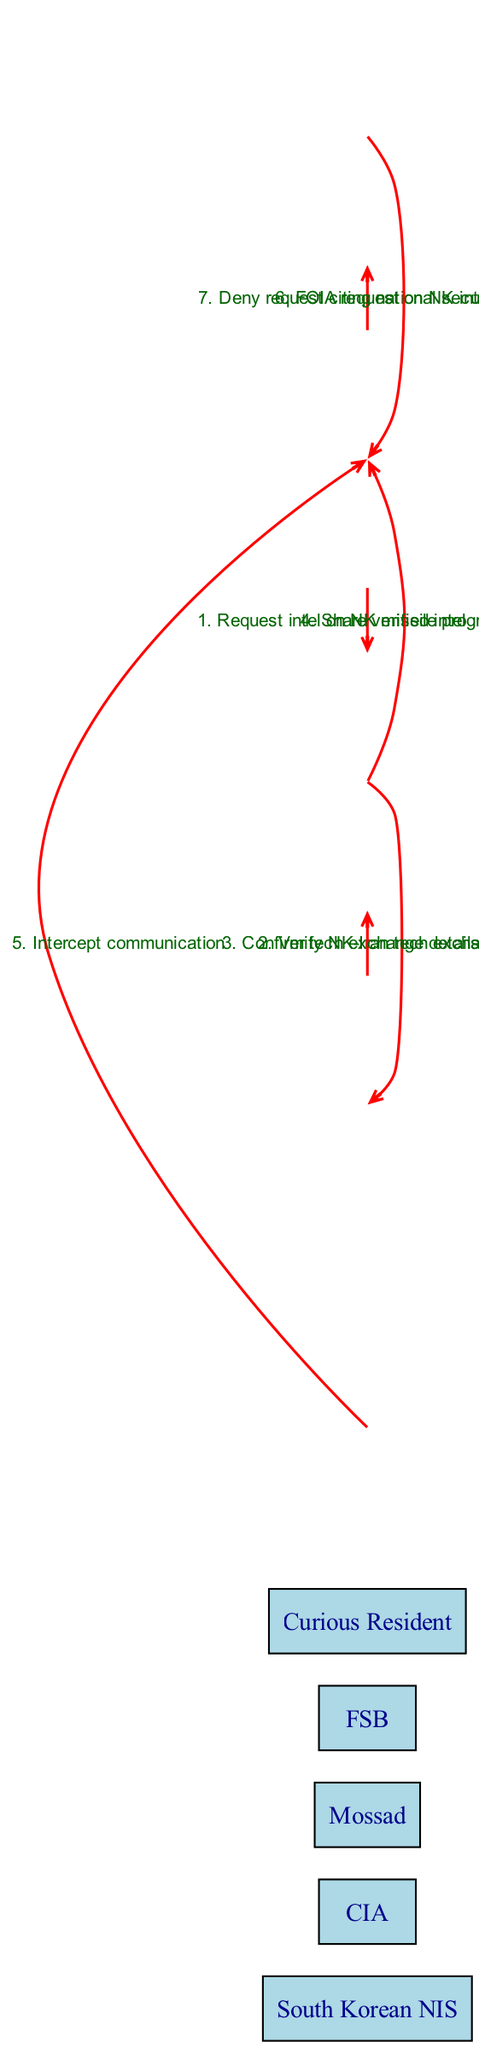What is the first message in the sequence? The first message is sent from the South Korean NIS to the CIA, where they request intelligence on the North Korean missile program.
Answer: Request intel on NK missile program How many total actors are represented in the diagram? There are a total of five actors represented: South Korean NIS, CIA, Mossad, FSB, and Curious Resident.
Answer: 5 Who is the last actor to send a message? The last actor to send a message is the South Korean NIS, which denies the Curious Resident's FOIA request.
Answer: South Korean NIS Which agency verifies the NK-Iran tech exchange? The CIA sends the verification request to Mossad, who confirms the details related to the NK-Iran tech exchange.
Answer: Mossad What is the response of the South Korean NIS to the Curious Resident's request? The South Korean NIS responds to the FOIA request by denying it, citing national security as the reason.
Answer: Deny request citing national security What is the relationship between the CIA and Mossad in this context? The CIA requests Mossad to verify intelligence regarding the NK-Iran tech exchange, indicating a collaborative relationship between the two agencies.
Answer: Collaborative How many messages are exchanged between the CIA and Mossad? Two messages are exchanged between the CIA and Mossad: one requesting verification and the other confirming the tech exchange details.
Answer: 2 What does the FSB communicate to the South Korean NIS? The FSB communicates to the South Korean NIS that they are intercepting communication.
Answer: Intercept communication Which actor initiates a request related to North Korean intel? The Curious Resident initiates a request about North Korean intelligence by submitting a FOIA request.
Answer: Curious Resident 